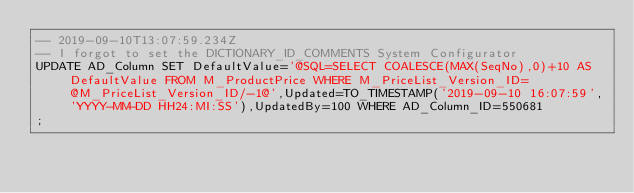<code> <loc_0><loc_0><loc_500><loc_500><_SQL_>-- 2019-09-10T13:07:59.234Z
-- I forgot to set the DICTIONARY_ID_COMMENTS System Configurator
UPDATE AD_Column SET DefaultValue='@SQL=SELECT COALESCE(MAX(SeqNo),0)+10 AS DefaultValue FROM M_ProductPrice WHERE M_PriceList_Version_ID=@M_PriceList_Version_ID/-1@',Updated=TO_TIMESTAMP('2019-09-10 16:07:59','YYYY-MM-DD HH24:MI:SS'),UpdatedBy=100 WHERE AD_Column_ID=550681
;

</code> 